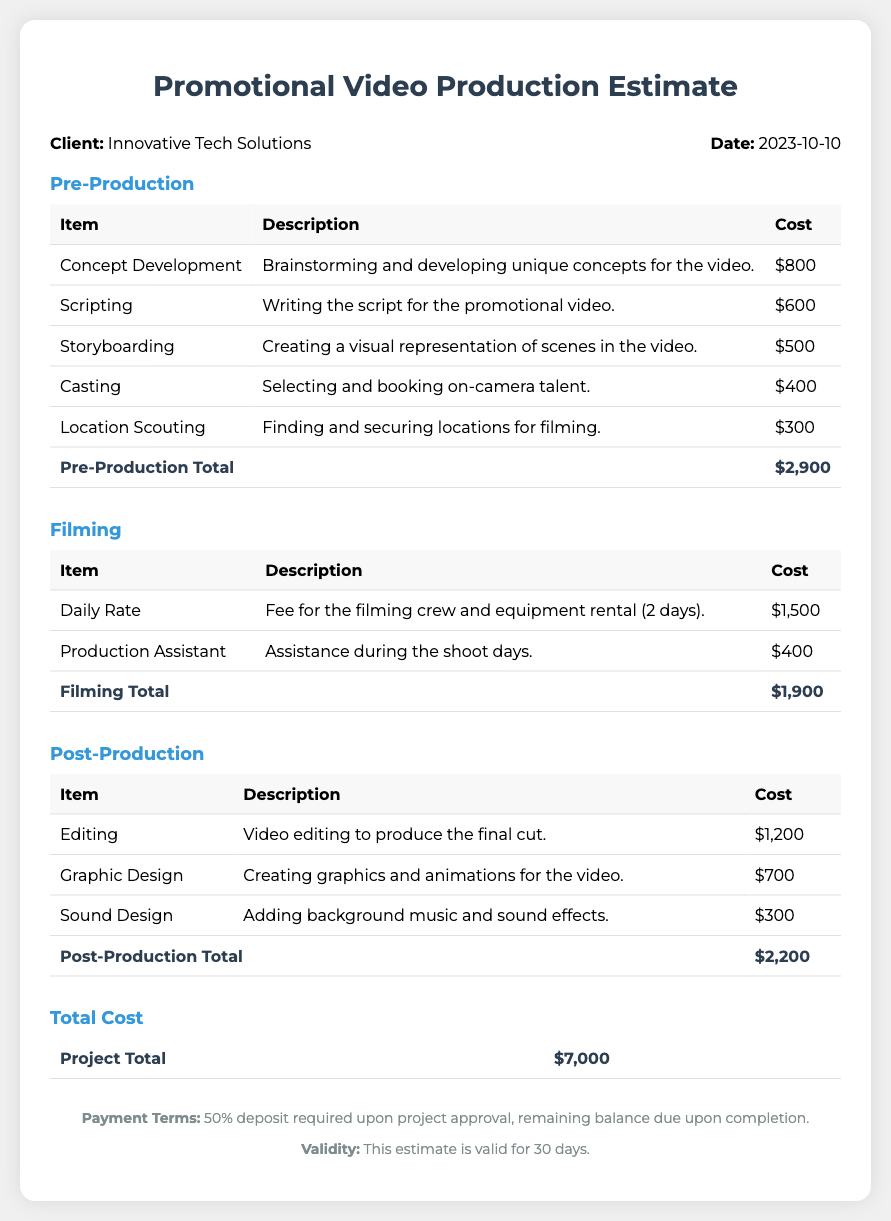what is the client name? The client name is provided in the header section of the document.
Answer: Innovative Tech Solutions what is the date of the estimate? The date of the estimate is found next to the client name in the header section.
Answer: 2023-10-10 how much does concept development cost? The cost for concept development is listed under the Pre-Production section.
Answer: $800 what is the total cost for Post-Production? The total cost for Post-Production is found in the Post-Production section's total row.
Answer: $2,200 how many days are included in the filming daily rate? The filming details specify the number of days for which the daily rate is applicable.
Answer: 2 days what is the payment term? The payment term is found in the footer of the document and specifies the conditions for payment.
Answer: 50% deposit required upon project approval what is the total project cost? The total project cost is provided in the Total Cost section of the document.
Answer: $7,000 how long is this estimate valid? The validity is mentioned in the footer section, indicating how long the estimate remains valid.
Answer: 30 days what item is associated with sound design? The Post-Production section details the services provided, including sound design.
Answer: Adding background music and sound effects 